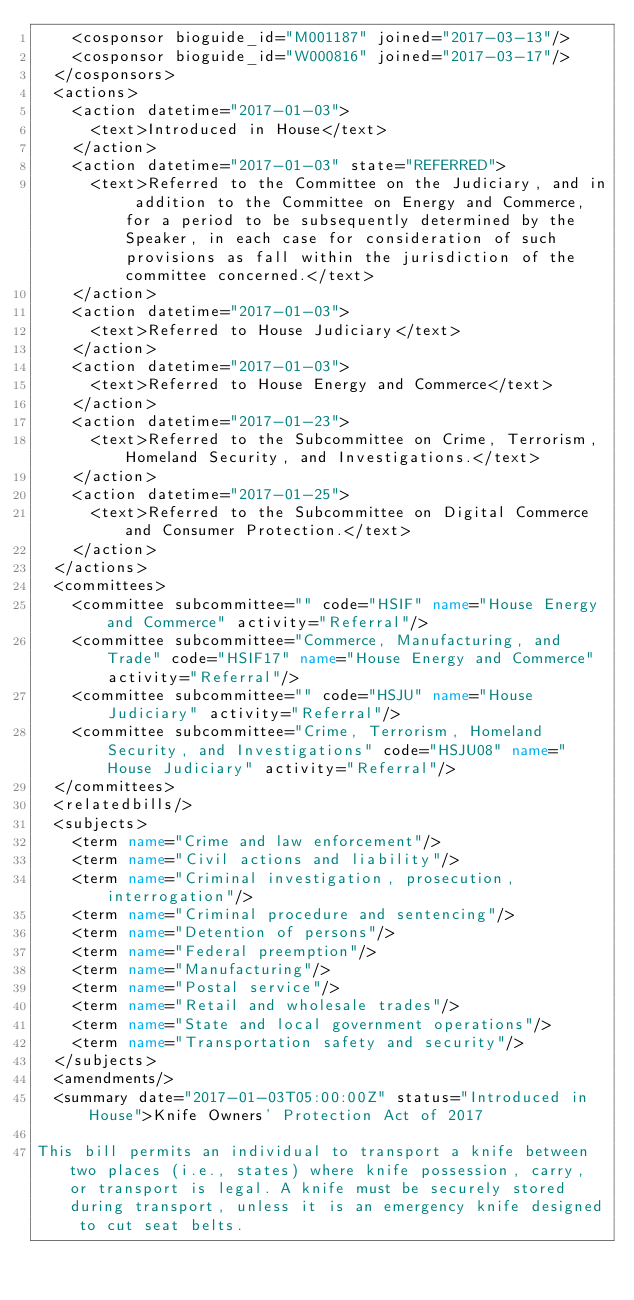<code> <loc_0><loc_0><loc_500><loc_500><_XML_>    <cosponsor bioguide_id="M001187" joined="2017-03-13"/>
    <cosponsor bioguide_id="W000816" joined="2017-03-17"/>
  </cosponsors>
  <actions>
    <action datetime="2017-01-03">
      <text>Introduced in House</text>
    </action>
    <action datetime="2017-01-03" state="REFERRED">
      <text>Referred to the Committee on the Judiciary, and in addition to the Committee on Energy and Commerce, for a period to be subsequently determined by the Speaker, in each case for consideration of such provisions as fall within the jurisdiction of the committee concerned.</text>
    </action>
    <action datetime="2017-01-03">
      <text>Referred to House Judiciary</text>
    </action>
    <action datetime="2017-01-03">
      <text>Referred to House Energy and Commerce</text>
    </action>
    <action datetime="2017-01-23">
      <text>Referred to the Subcommittee on Crime, Terrorism, Homeland Security, and Investigations.</text>
    </action>
    <action datetime="2017-01-25">
      <text>Referred to the Subcommittee on Digital Commerce and Consumer Protection.</text>
    </action>
  </actions>
  <committees>
    <committee subcommittee="" code="HSIF" name="House Energy and Commerce" activity="Referral"/>
    <committee subcommittee="Commerce, Manufacturing, and Trade" code="HSIF17" name="House Energy and Commerce" activity="Referral"/>
    <committee subcommittee="" code="HSJU" name="House Judiciary" activity="Referral"/>
    <committee subcommittee="Crime, Terrorism, Homeland Security, and Investigations" code="HSJU08" name="House Judiciary" activity="Referral"/>
  </committees>
  <relatedbills/>
  <subjects>
    <term name="Crime and law enforcement"/>
    <term name="Civil actions and liability"/>
    <term name="Criminal investigation, prosecution, interrogation"/>
    <term name="Criminal procedure and sentencing"/>
    <term name="Detention of persons"/>
    <term name="Federal preemption"/>
    <term name="Manufacturing"/>
    <term name="Postal service"/>
    <term name="Retail and wholesale trades"/>
    <term name="State and local government operations"/>
    <term name="Transportation safety and security"/>
  </subjects>
  <amendments/>
  <summary date="2017-01-03T05:00:00Z" status="Introduced in House">Knife Owners' Protection Act of 2017

This bill permits an individual to transport a knife between two places (i.e., states) where knife possession, carry, or transport is legal. A knife must be securely stored during transport, unless it is an emergency knife designed to cut seat belts.
</code> 